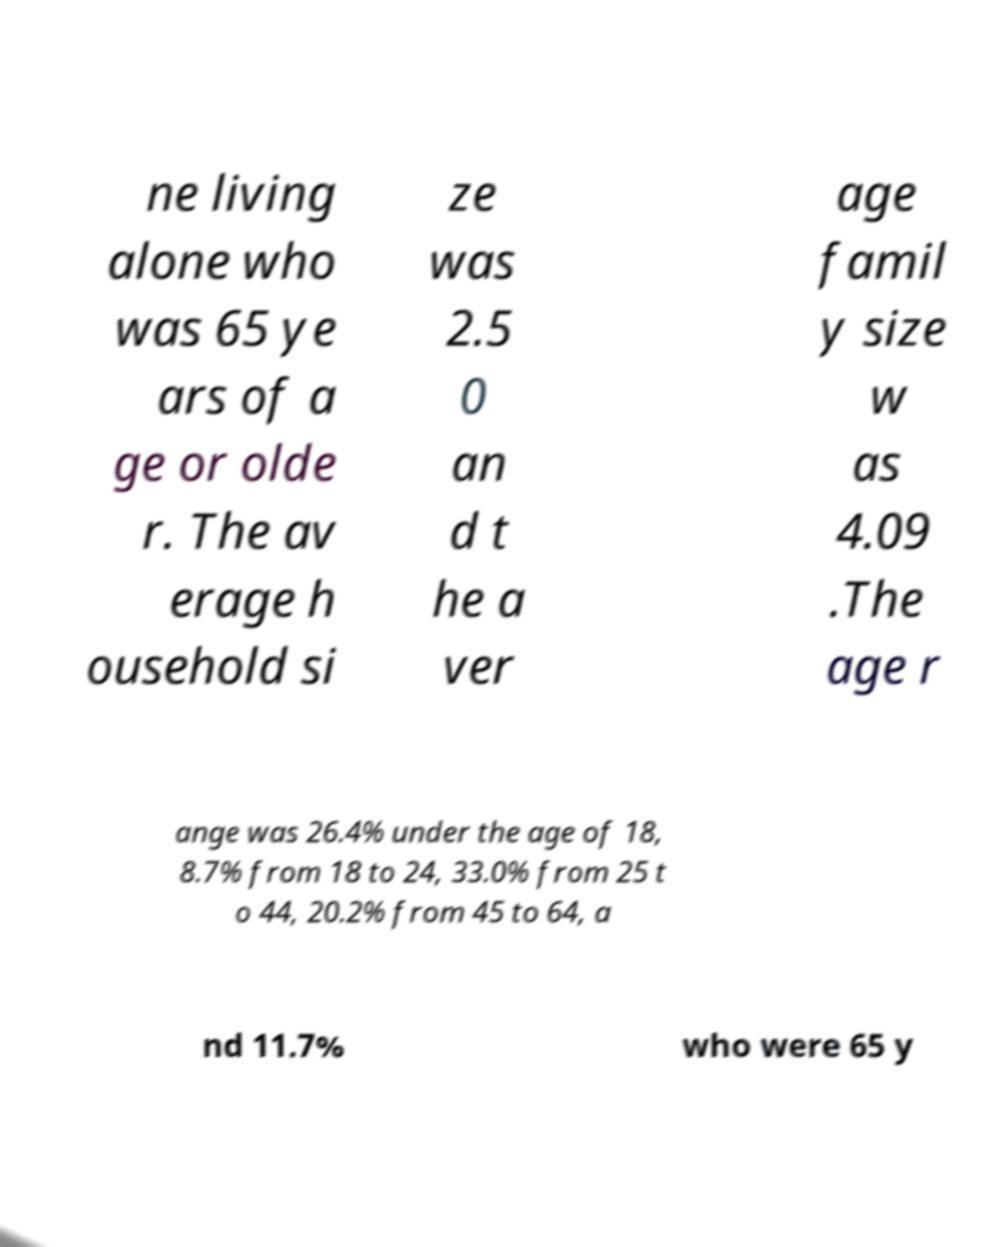I need the written content from this picture converted into text. Can you do that? ne living alone who was 65 ye ars of a ge or olde r. The av erage h ousehold si ze was 2.5 0 an d t he a ver age famil y size w as 4.09 .The age r ange was 26.4% under the age of 18, 8.7% from 18 to 24, 33.0% from 25 t o 44, 20.2% from 45 to 64, a nd 11.7% who were 65 y 